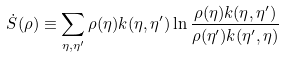Convert formula to latex. <formula><loc_0><loc_0><loc_500><loc_500>\dot { S } ( \rho ) \equiv \sum _ { \eta , \eta ^ { \prime } } \rho ( \eta ) k ( \eta , \eta ^ { \prime } ) \ln \frac { \rho ( \eta ) k ( \eta , \eta ^ { \prime } ) } { \rho ( \eta ^ { \prime } ) k ( \eta ^ { \prime } , \eta ) }</formula> 